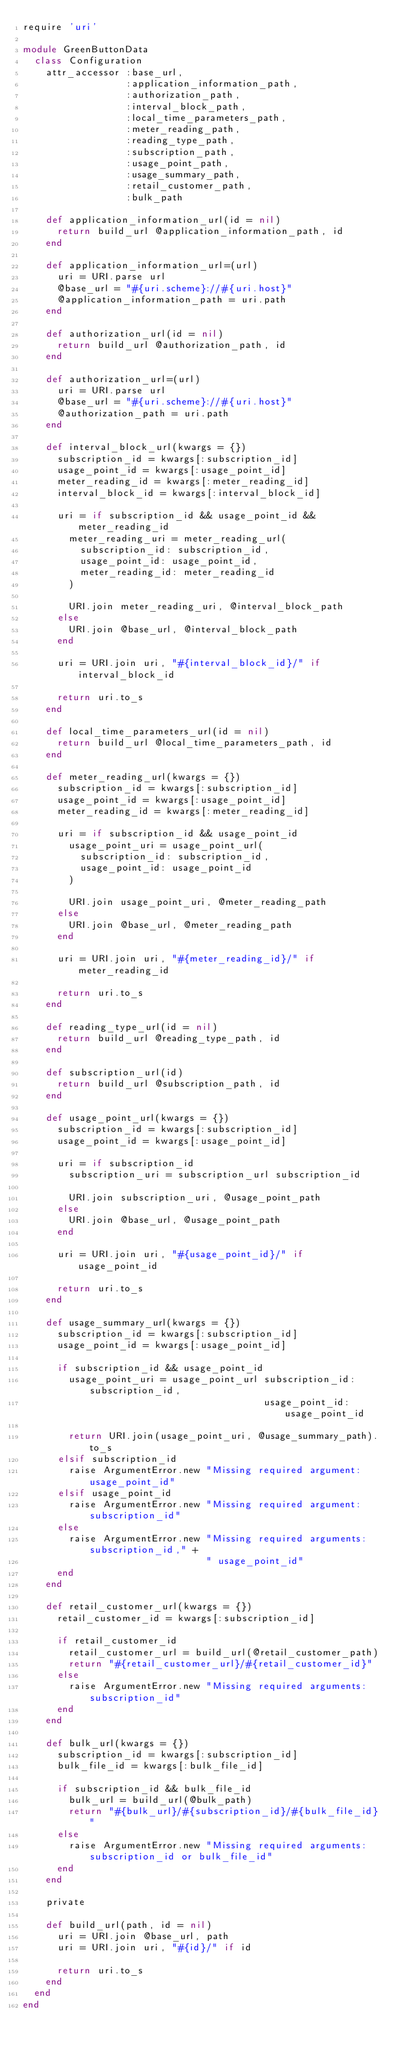Convert code to text. <code><loc_0><loc_0><loc_500><loc_500><_Ruby_>require 'uri'

module GreenButtonData
  class Configuration
    attr_accessor :base_url,
                  :application_information_path,
                  :authorization_path,
                  :interval_block_path,
                  :local_time_parameters_path,
                  :meter_reading_path,
                  :reading_type_path,
                  :subscription_path,
                  :usage_point_path,
                  :usage_summary_path,
                  :retail_customer_path,
                  :bulk_path

    def application_information_url(id = nil)
      return build_url @application_information_path, id
    end

    def application_information_url=(url)
      uri = URI.parse url
      @base_url = "#{uri.scheme}://#{uri.host}"
      @application_information_path = uri.path
    end

    def authorization_url(id = nil)
      return build_url @authorization_path, id
    end

    def authorization_url=(url)
      uri = URI.parse url
      @base_url = "#{uri.scheme}://#{uri.host}"
      @authorization_path = uri.path
    end

    def interval_block_url(kwargs = {})
      subscription_id = kwargs[:subscription_id]
      usage_point_id = kwargs[:usage_point_id]
      meter_reading_id = kwargs[:meter_reading_id]
      interval_block_id = kwargs[:interval_block_id]

      uri = if subscription_id && usage_point_id && meter_reading_id
        meter_reading_uri = meter_reading_url(
          subscription_id: subscription_id,
          usage_point_id: usage_point_id,
          meter_reading_id: meter_reading_id
        )

        URI.join meter_reading_uri, @interval_block_path
      else
        URI.join @base_url, @interval_block_path
      end

      uri = URI.join uri, "#{interval_block_id}/" if interval_block_id

      return uri.to_s
    end

    def local_time_parameters_url(id = nil)
      return build_url @local_time_parameters_path, id
    end

    def meter_reading_url(kwargs = {})
      subscription_id = kwargs[:subscription_id]
      usage_point_id = kwargs[:usage_point_id]
      meter_reading_id = kwargs[:meter_reading_id]

      uri = if subscription_id && usage_point_id
        usage_point_uri = usage_point_url(
          subscription_id: subscription_id,
          usage_point_id: usage_point_id
        )

        URI.join usage_point_uri, @meter_reading_path
      else
        URI.join @base_url, @meter_reading_path
      end

      uri = URI.join uri, "#{meter_reading_id}/" if meter_reading_id

      return uri.to_s
    end

    def reading_type_url(id = nil)
      return build_url @reading_type_path, id
    end

    def subscription_url(id)
      return build_url @subscription_path, id
    end

    def usage_point_url(kwargs = {})
      subscription_id = kwargs[:subscription_id]
      usage_point_id = kwargs[:usage_point_id]

      uri = if subscription_id
        subscription_uri = subscription_url subscription_id

        URI.join subscription_uri, @usage_point_path
      else
        URI.join @base_url, @usage_point_path
      end

      uri = URI.join uri, "#{usage_point_id}/" if usage_point_id

      return uri.to_s
    end

    def usage_summary_url(kwargs = {})
      subscription_id = kwargs[:subscription_id]
      usage_point_id = kwargs[:usage_point_id]

      if subscription_id && usage_point_id
        usage_point_uri = usage_point_url subscription_id: subscription_id,
                                          usage_point_id: usage_point_id

        return URI.join(usage_point_uri, @usage_summary_path).to_s
      elsif subscription_id
        raise ArgumentError.new "Missing required argument: usage_point_id"
      elsif usage_point_id
        raise ArgumentError.new "Missing required argument: subscription_id"
      else
        raise ArgumentError.new "Missing required arguments: subscription_id," +
                                " usage_point_id"
      end
    end

    def retail_customer_url(kwargs = {})
      retail_customer_id = kwargs[:subscription_id]

      if retail_customer_id
        retail_customer_url = build_url(@retail_customer_path)
        return "#{retail_customer_url}/#{retail_customer_id}"
      else
        raise ArgumentError.new "Missing required arguments: subscription_id"
      end
    end

    def bulk_url(kwargs = {})
      subscription_id = kwargs[:subscription_id]
      bulk_file_id = kwargs[:bulk_file_id]

      if subscription_id && bulk_file_id
        bulk_url = build_url(@bulk_path)
        return "#{bulk_url}/#{subscription_id}/#{bulk_file_id}"
      else
        raise ArgumentError.new "Missing required arguments: subscription_id or bulk_file_id"
      end
    end

    private

    def build_url(path, id = nil)
      uri = URI.join @base_url, path
      uri = URI.join uri, "#{id}/" if id

      return uri.to_s
    end
  end
end
</code> 